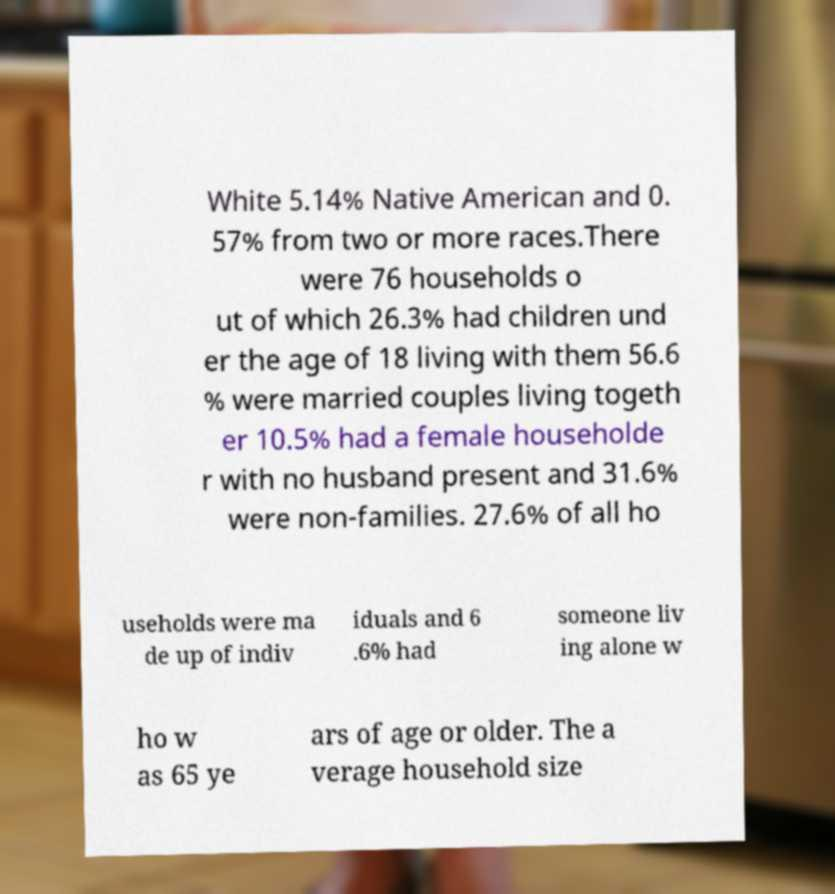I need the written content from this picture converted into text. Can you do that? White 5.14% Native American and 0. 57% from two or more races.There were 76 households o ut of which 26.3% had children und er the age of 18 living with them 56.6 % were married couples living togeth er 10.5% had a female householde r with no husband present and 31.6% were non-families. 27.6% of all ho useholds were ma de up of indiv iduals and 6 .6% had someone liv ing alone w ho w as 65 ye ars of age or older. The a verage household size 